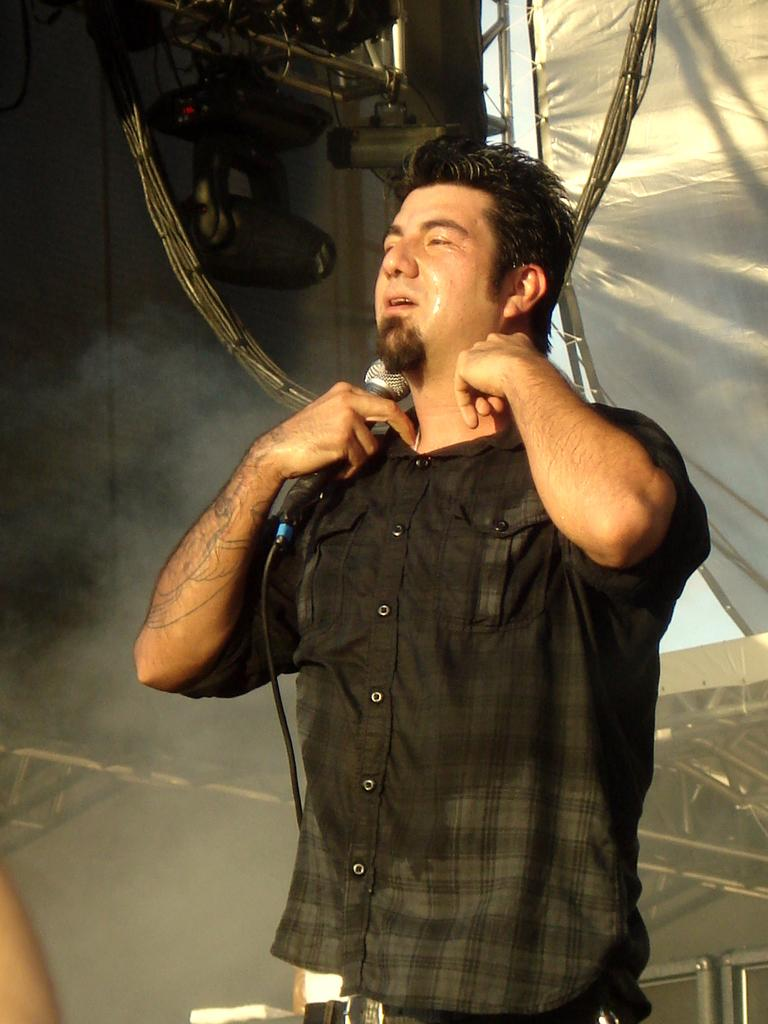Who is present in the image? There is a person in the image. What is the person wearing? The person is wearing a green shirt. What is the person holding in their right hand? The person is holding a mic in their right hand. What type of bread is the person eating in the image? There is no bread present in the image; the person is holding a mic. 